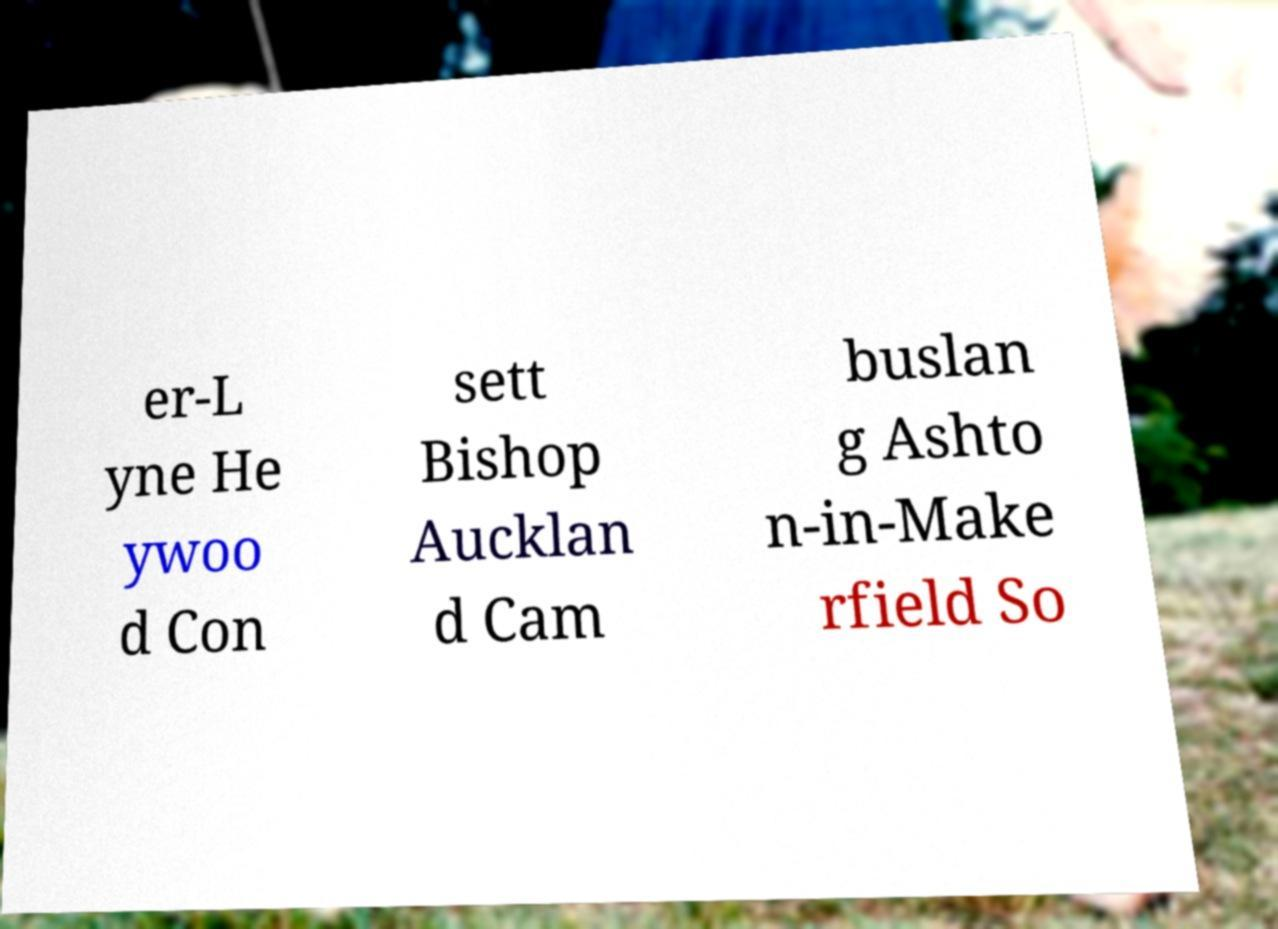I need the written content from this picture converted into text. Can you do that? er-L yne He ywoo d Con sett Bishop Aucklan d Cam buslan g Ashto n-in-Make rfield So 